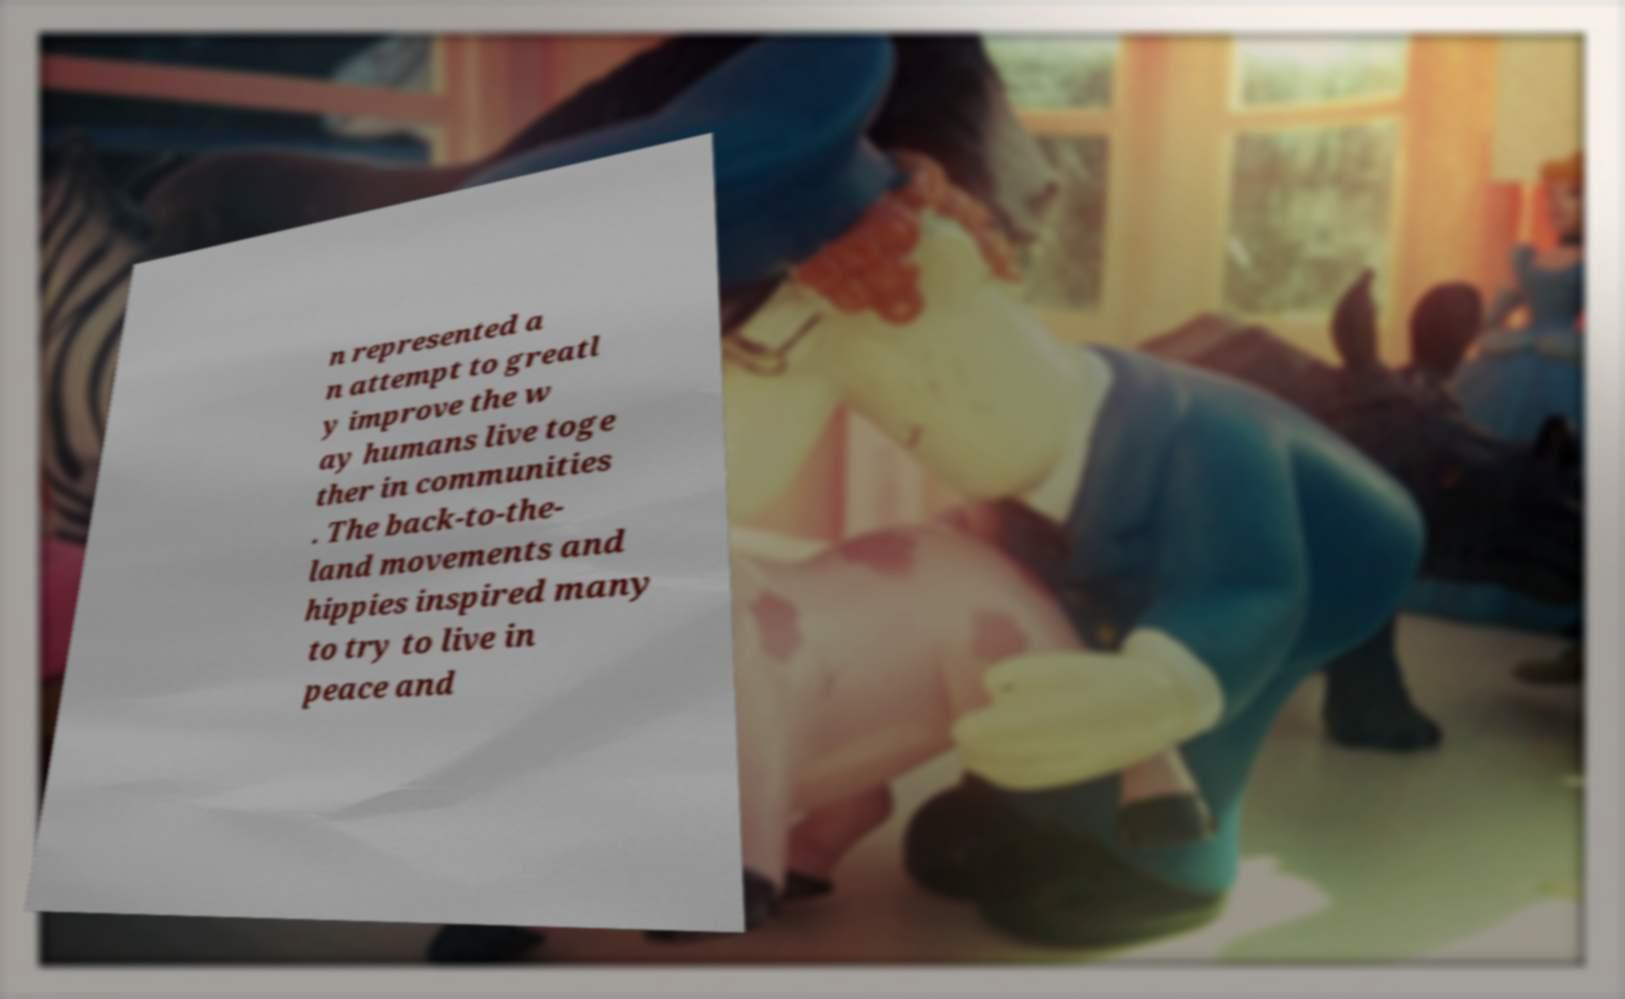Can you accurately transcribe the text from the provided image for me? n represented a n attempt to greatl y improve the w ay humans live toge ther in communities . The back-to-the- land movements and hippies inspired many to try to live in peace and 